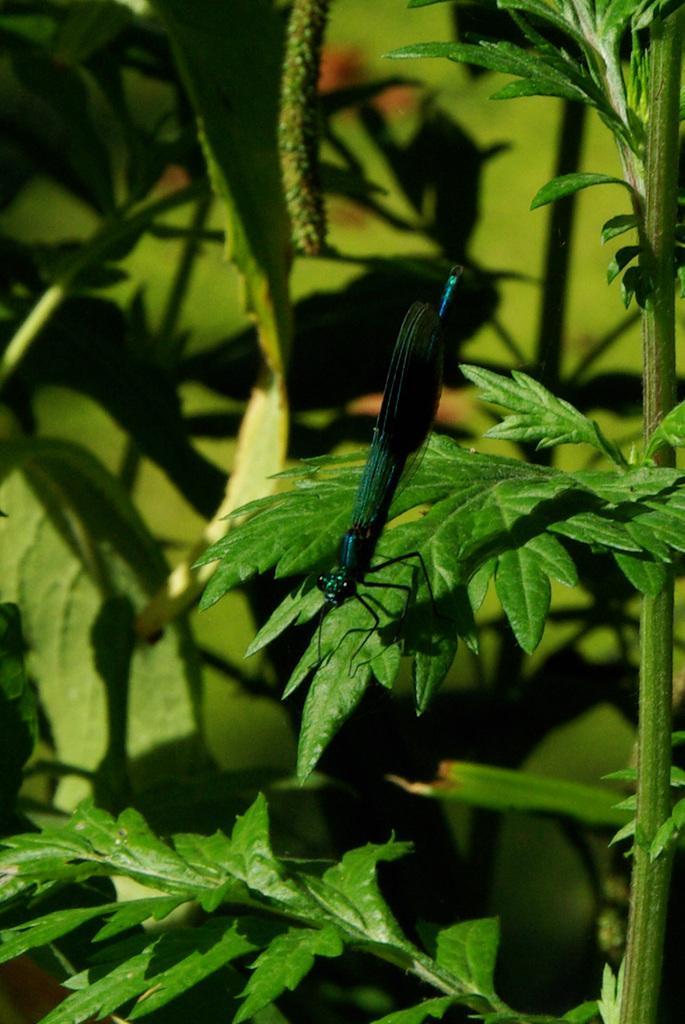In one or two sentences, can you explain what this image depicts? This is the picture of a grasshopper which is on the leaf to the plant and behind there are some other plants. 